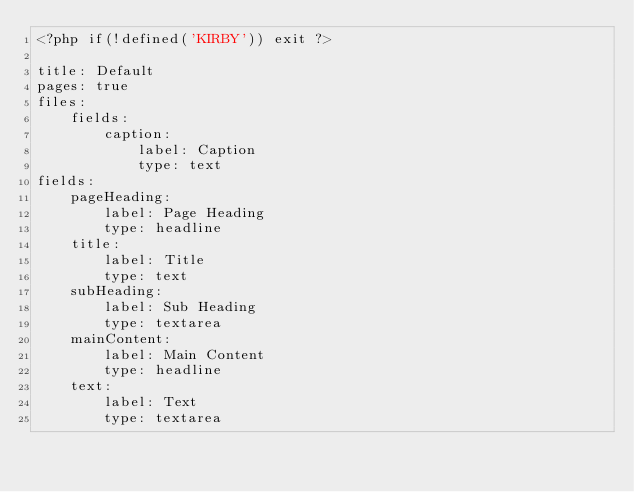<code> <loc_0><loc_0><loc_500><loc_500><_PHP_><?php if(!defined('KIRBY')) exit ?>

title: Default
pages: true
files:
	fields:
		caption:
			label: Caption
			type: text
fields:
	pageHeading:
	    label: Page Heading
	    type: headline
	title:
		label: Title
		type: text
	subHeading:
		label: Sub Heading
		type: textarea
	mainContent:
	    label: Main Content
	    type: headline
	text:
		label: Text
		type: textarea</code> 